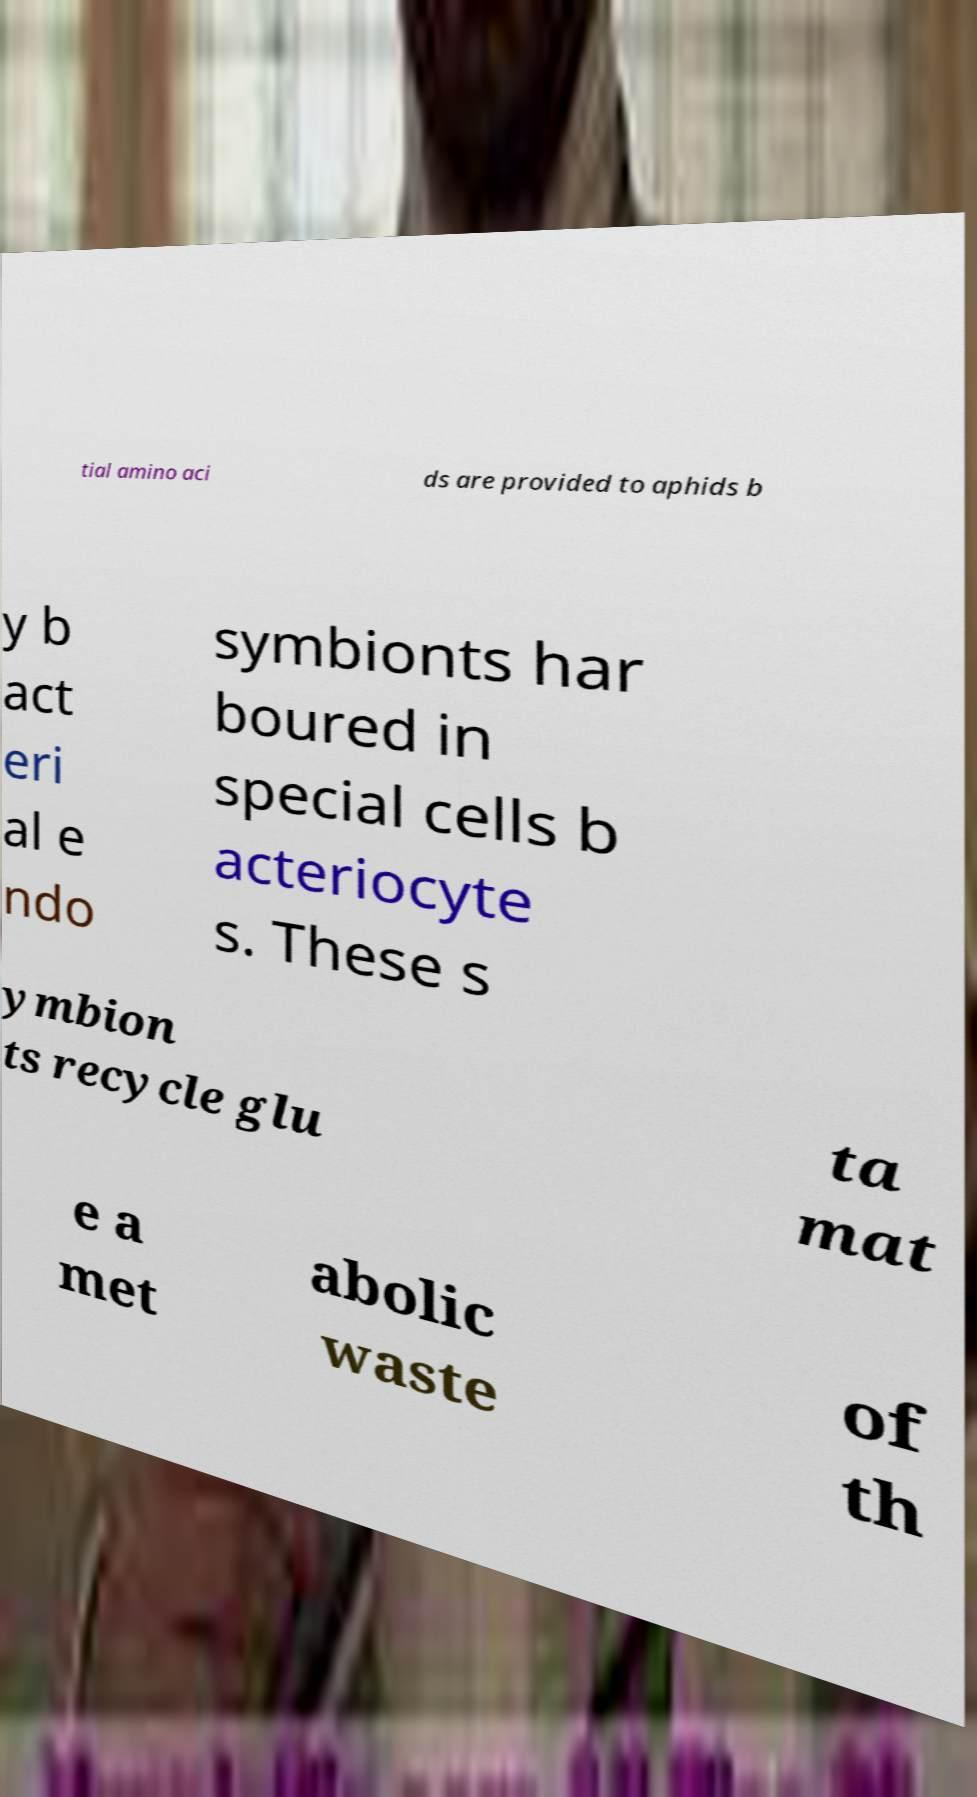What messages or text are displayed in this image? I need them in a readable, typed format. tial amino aci ds are provided to aphids b y b act eri al e ndo symbionts har boured in special cells b acteriocyte s. These s ymbion ts recycle glu ta mat e a met abolic waste of th 